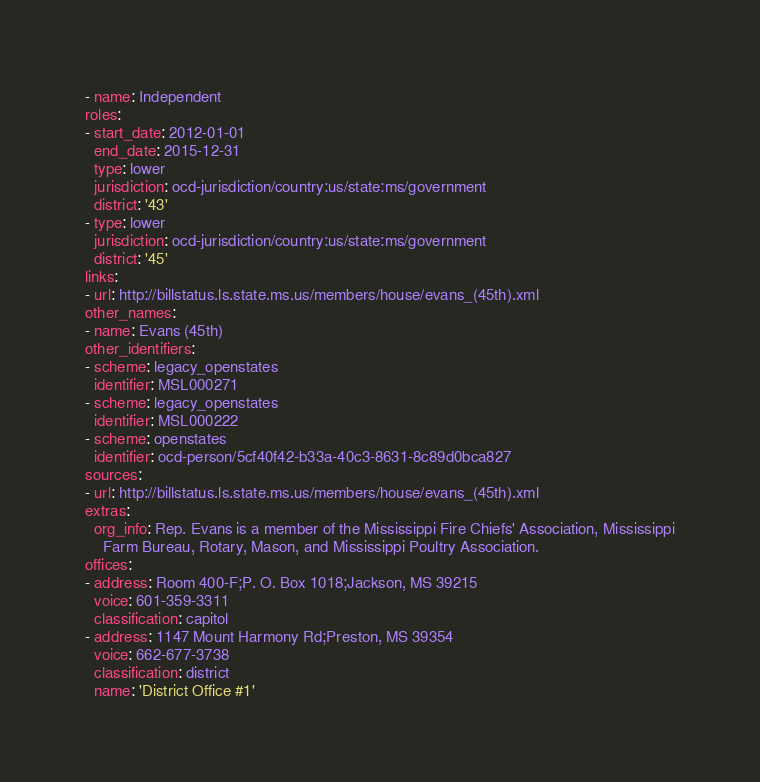<code> <loc_0><loc_0><loc_500><loc_500><_YAML_>- name: Independent
roles:
- start_date: 2012-01-01
  end_date: 2015-12-31
  type: lower
  jurisdiction: ocd-jurisdiction/country:us/state:ms/government
  district: '43'
- type: lower
  jurisdiction: ocd-jurisdiction/country:us/state:ms/government
  district: '45'
links:
- url: http://billstatus.ls.state.ms.us/members/house/evans_(45th).xml
other_names:
- name: Evans (45th)
other_identifiers:
- scheme: legacy_openstates
  identifier: MSL000271
- scheme: legacy_openstates
  identifier: MSL000222
- scheme: openstates
  identifier: ocd-person/5cf40f42-b33a-40c3-8631-8c89d0bca827
sources:
- url: http://billstatus.ls.state.ms.us/members/house/evans_(45th).xml
extras:
  org_info: Rep. Evans is a member of the Mississippi Fire Chiefs' Association, Mississippi
    Farm Bureau, Rotary, Mason, and Mississippi Poultry Association.
offices:
- address: Room 400-F;P. O. Box 1018;Jackson, MS 39215
  voice: 601-359-3311
  classification: capitol
- address: 1147 Mount Harmony Rd;Preston, MS 39354
  voice: 662-677-3738
  classification: district
  name: 'District Office #1'
</code> 